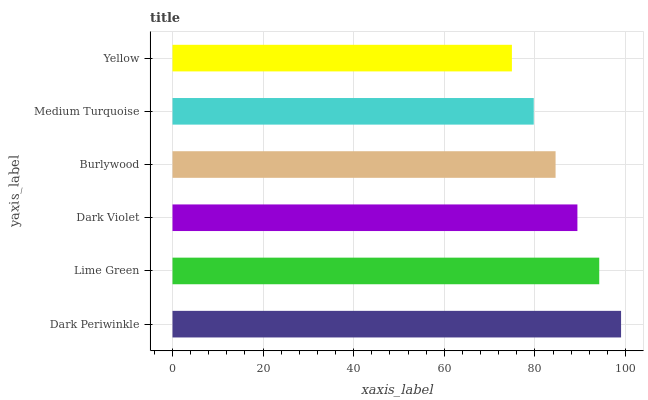Is Yellow the minimum?
Answer yes or no. Yes. Is Dark Periwinkle the maximum?
Answer yes or no. Yes. Is Lime Green the minimum?
Answer yes or no. No. Is Lime Green the maximum?
Answer yes or no. No. Is Dark Periwinkle greater than Lime Green?
Answer yes or no. Yes. Is Lime Green less than Dark Periwinkle?
Answer yes or no. Yes. Is Lime Green greater than Dark Periwinkle?
Answer yes or no. No. Is Dark Periwinkle less than Lime Green?
Answer yes or no. No. Is Dark Violet the high median?
Answer yes or no. Yes. Is Burlywood the low median?
Answer yes or no. Yes. Is Medium Turquoise the high median?
Answer yes or no. No. Is Lime Green the low median?
Answer yes or no. No. 